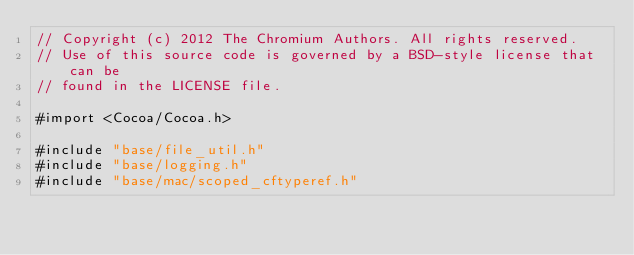Convert code to text. <code><loc_0><loc_0><loc_500><loc_500><_ObjectiveC_>// Copyright (c) 2012 The Chromium Authors. All rights reserved.
// Use of this source code is governed by a BSD-style license that can be
// found in the LICENSE file.

#import <Cocoa/Cocoa.h>

#include "base/file_util.h"
#include "base/logging.h"
#include "base/mac/scoped_cftyperef.h"</code> 